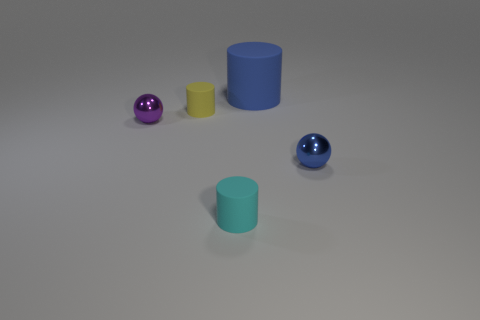Is there anything else that is the same size as the blue cylinder?
Provide a short and direct response. No. There is a large matte cylinder; does it have the same color as the small metal object that is in front of the tiny purple thing?
Your answer should be very brief. Yes. Is there a metallic ball that has the same color as the big cylinder?
Your answer should be compact. Yes. There is a ball that is the same color as the big object; what is it made of?
Keep it short and to the point. Metal. Is the number of small cyan matte blocks greater than the number of yellow rubber things?
Ensure brevity in your answer.  No. What number of things are small metallic spheres or metallic objects that are on the left side of the blue cylinder?
Offer a terse response. 2. What number of other objects are the same shape as the small cyan thing?
Your answer should be very brief. 2. Are there fewer small metal balls to the left of the large blue object than small things that are behind the cyan matte cylinder?
Keep it short and to the point. Yes. There is a tiny yellow thing that is made of the same material as the cyan thing; what is its shape?
Provide a succinct answer. Cylinder. There is a metal ball that is to the left of the cylinder that is right of the cyan rubber cylinder; what color is it?
Your response must be concise. Purple. 